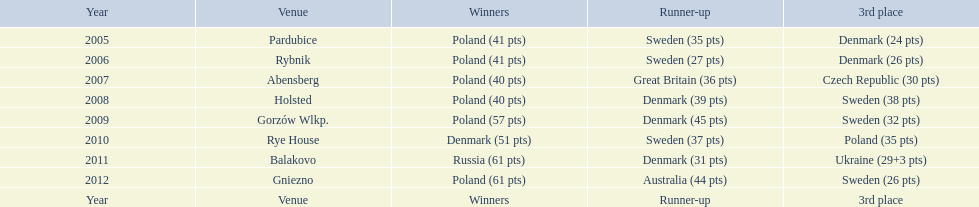Following their first place victory in 2009, what was poland's position in the 2010 speedway junior world championship? 3rd place. 